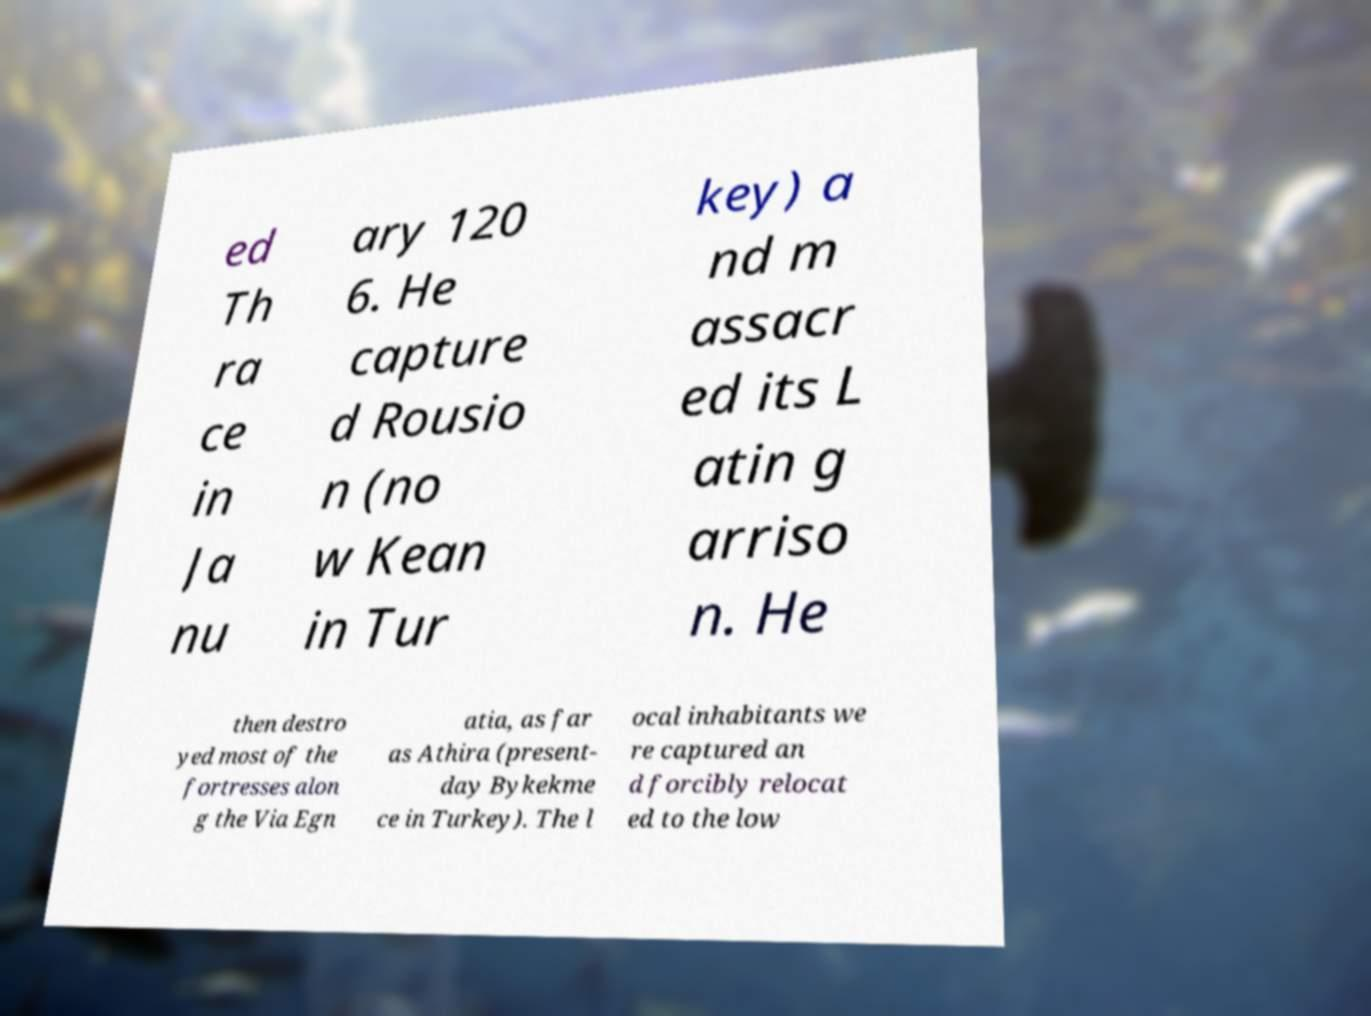There's text embedded in this image that I need extracted. Can you transcribe it verbatim? ed Th ra ce in Ja nu ary 120 6. He capture d Rousio n (no w Kean in Tur key) a nd m assacr ed its L atin g arriso n. He then destro yed most of the fortresses alon g the Via Egn atia, as far as Athira (present- day Bykekme ce in Turkey). The l ocal inhabitants we re captured an d forcibly relocat ed to the low 